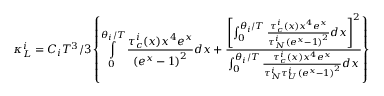Convert formula to latex. <formula><loc_0><loc_0><loc_500><loc_500>\kappa _ { L } ^ { i } = C _ { i } T ^ { 3 } / 3 \left \{ \int o p _ { 0 } ^ { \theta _ { i } / T } \frac { \tau _ { c } ^ { i } ( x ) x ^ { 4 } e ^ { x } } { \left ( e ^ { x } - 1 \right ) ^ { 2 } } d x + \frac { \left [ \int o p _ { 0 } ^ { \theta _ { i } / T } \frac { \tau _ { c } ^ { i } ( x ) x ^ { 4 } e ^ { x } } { \tau _ { N } ^ { i } \left ( e ^ { x } - 1 \right ) ^ { 2 } } d x \right ] ^ { 2 } } { \int o p _ { 0 } ^ { \theta _ { i } / T } \frac { \tau _ { c } ^ { i } ( x ) x ^ { 4 } e ^ { x } } { \tau _ { N } ^ { i } \tau _ { U } ^ { i } \left ( e ^ { x } - 1 \right ) ^ { 2 } } d x } \right \}</formula> 